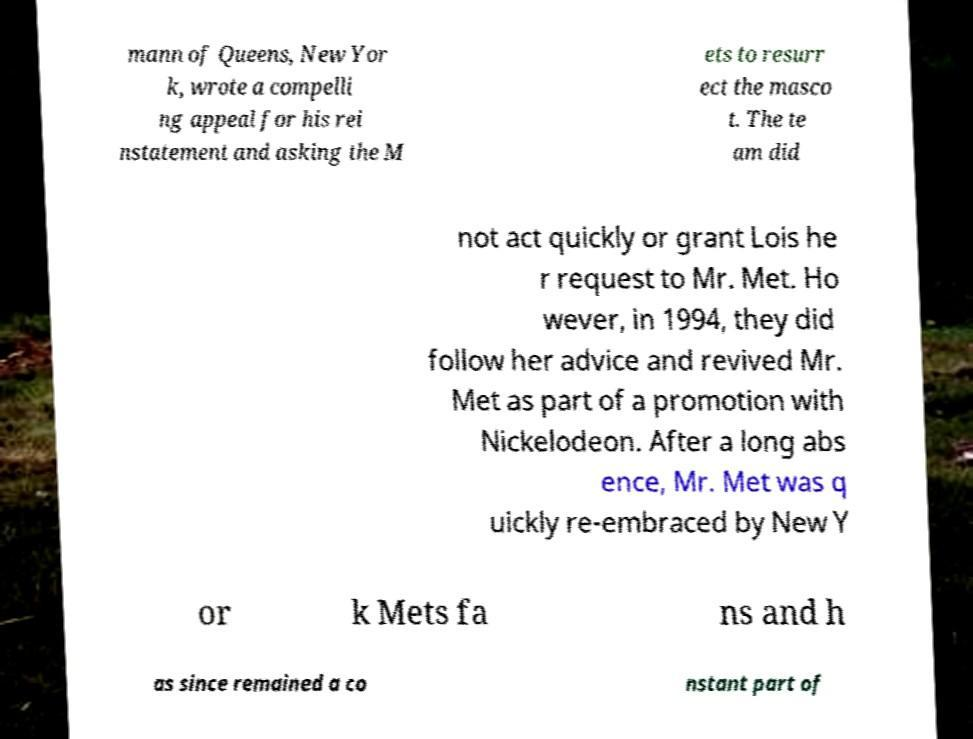Can you accurately transcribe the text from the provided image for me? mann of Queens, New Yor k, wrote a compelli ng appeal for his rei nstatement and asking the M ets to resurr ect the masco t. The te am did not act quickly or grant Lois he r request to Mr. Met. Ho wever, in 1994, they did follow her advice and revived Mr. Met as part of a promotion with Nickelodeon. After a long abs ence, Mr. Met was q uickly re-embraced by New Y or k Mets fa ns and h as since remained a co nstant part of 